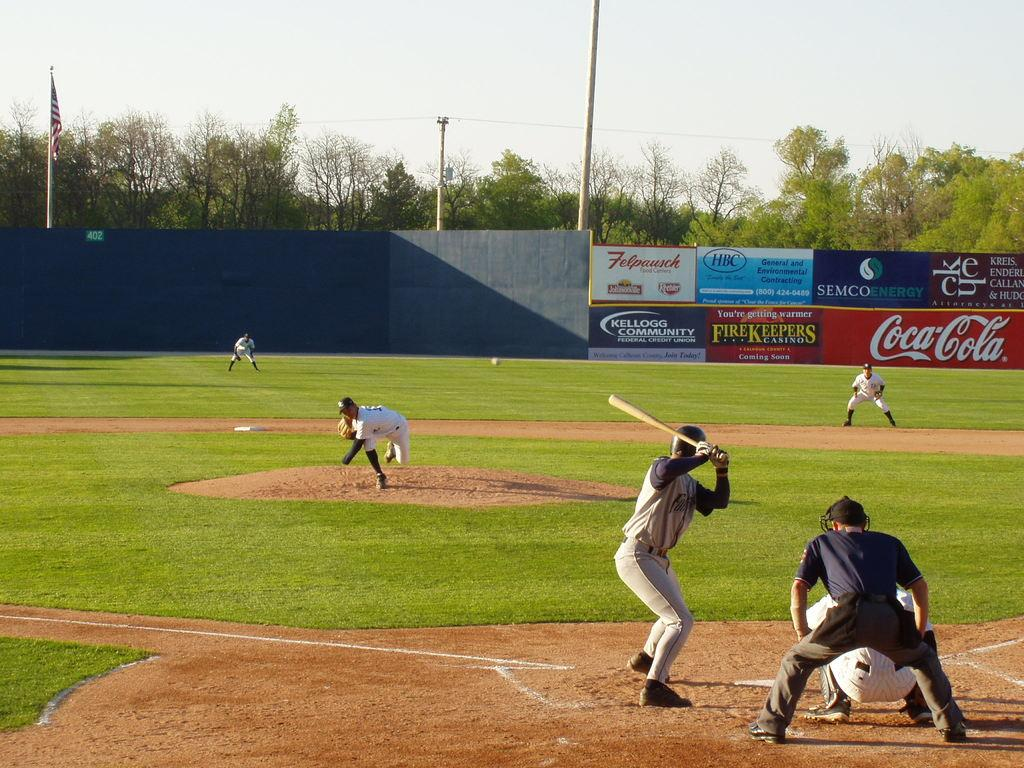<image>
Offer a succinct explanation of the picture presented. a baseball game going on with banners on the side that say Coca Cola, Felpausch and more. 